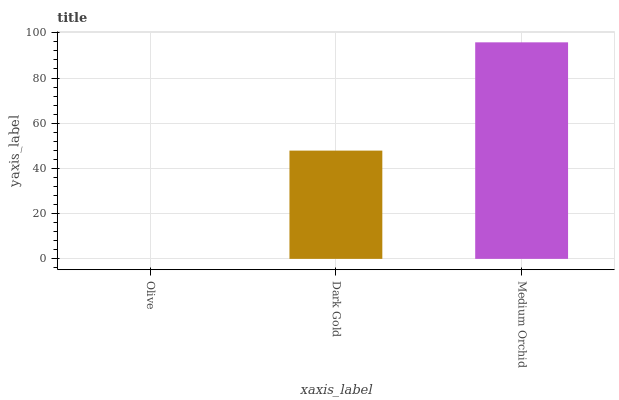Is Olive the minimum?
Answer yes or no. Yes. Is Medium Orchid the maximum?
Answer yes or no. Yes. Is Dark Gold the minimum?
Answer yes or no. No. Is Dark Gold the maximum?
Answer yes or no. No. Is Dark Gold greater than Olive?
Answer yes or no. Yes. Is Olive less than Dark Gold?
Answer yes or no. Yes. Is Olive greater than Dark Gold?
Answer yes or no. No. Is Dark Gold less than Olive?
Answer yes or no. No. Is Dark Gold the high median?
Answer yes or no. Yes. Is Dark Gold the low median?
Answer yes or no. Yes. Is Olive the high median?
Answer yes or no. No. Is Medium Orchid the low median?
Answer yes or no. No. 